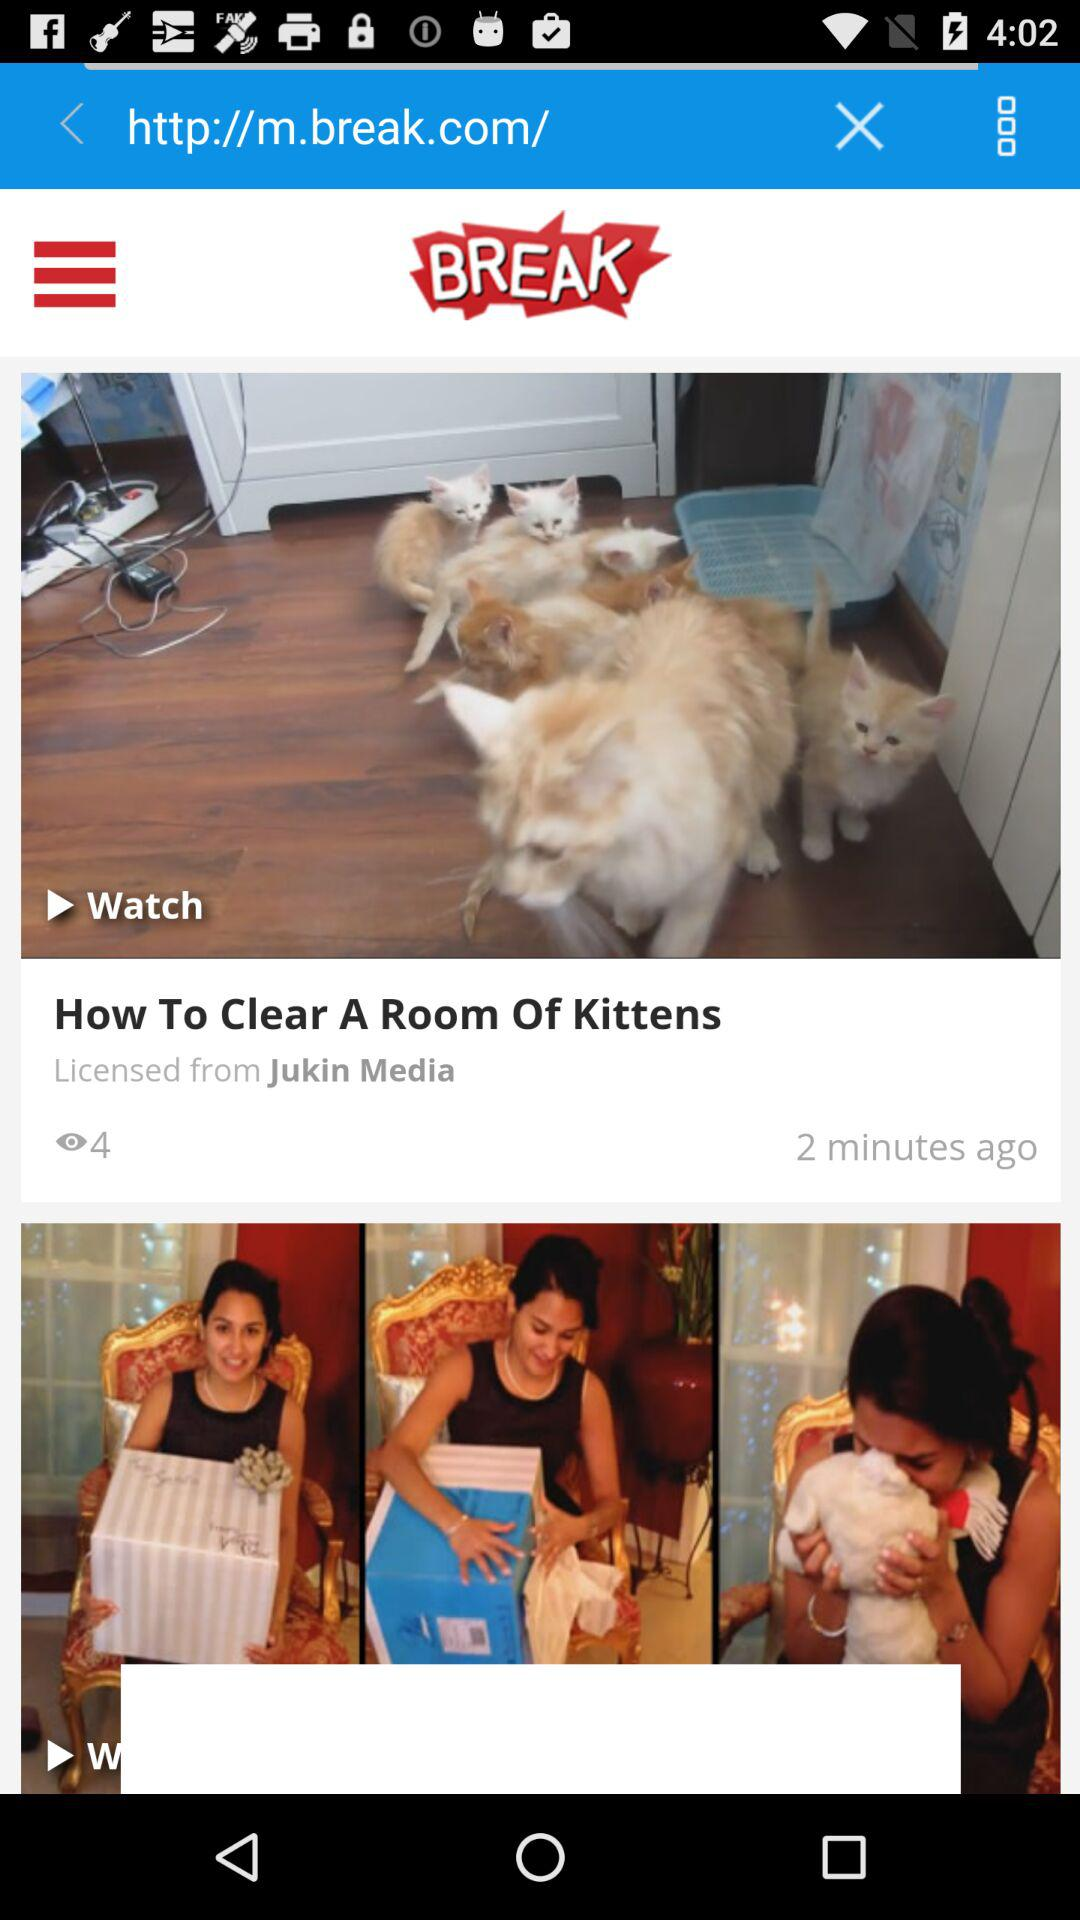Who holds the license to the "How To Clear A Room Of Kittens" video? The license is held by "Jukin Media". 